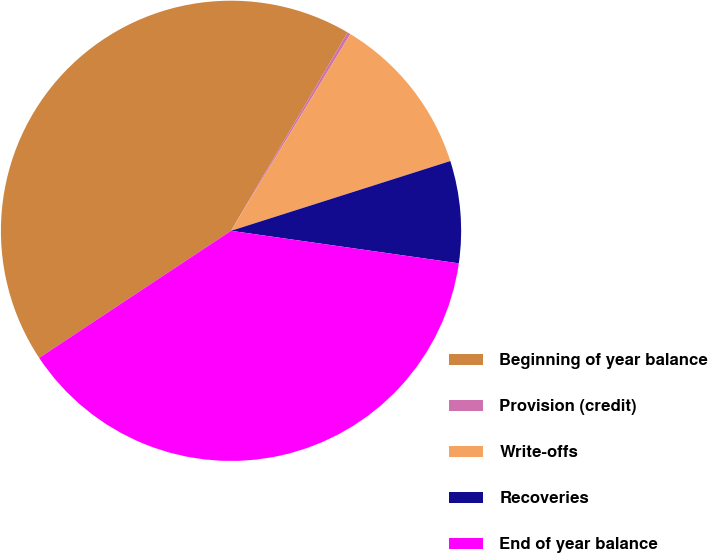<chart> <loc_0><loc_0><loc_500><loc_500><pie_chart><fcel>Beginning of year balance<fcel>Provision (credit)<fcel>Write-offs<fcel>Recoveries<fcel>End of year balance<nl><fcel>42.77%<fcel>0.22%<fcel>11.42%<fcel>7.16%<fcel>38.43%<nl></chart> 